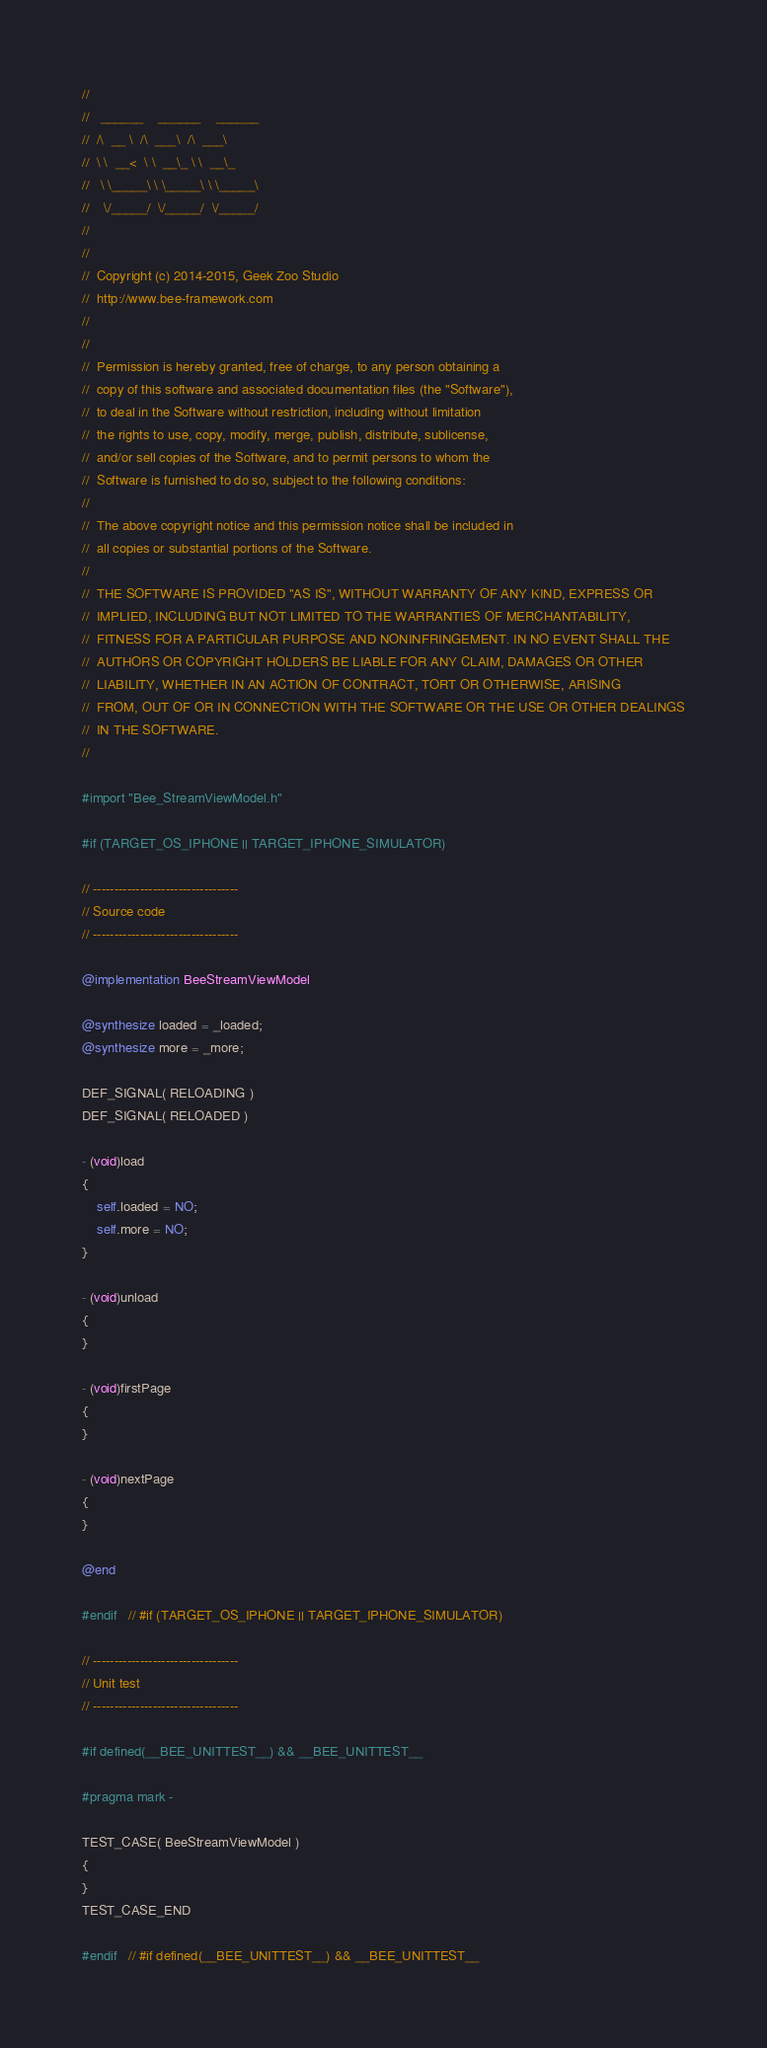<code> <loc_0><loc_0><loc_500><loc_500><_ObjectiveC_>//
//	 ______    ______    ______
//	/\  __ \  /\  ___\  /\  ___\
//	\ \  __<  \ \  __\_ \ \  __\_
//	 \ \_____\ \ \_____\ \ \_____\
//	  \/_____/  \/_____/  \/_____/
//
//
//	Copyright (c) 2014-2015, Geek Zoo Studio
//	http://www.bee-framework.com
//
//
//	Permission is hereby granted, free of charge, to any person obtaining a
//	copy of this software and associated documentation files (the "Software"),
//	to deal in the Software without restriction, including without limitation
//	the rights to use, copy, modify, merge, publish, distribute, sublicense,
//	and/or sell copies of the Software, and to permit persons to whom the
//	Software is furnished to do so, subject to the following conditions:
//
//	The above copyright notice and this permission notice shall be included in
//	all copies or substantial portions of the Software.
//
//	THE SOFTWARE IS PROVIDED "AS IS", WITHOUT WARRANTY OF ANY KIND, EXPRESS OR
//	IMPLIED, INCLUDING BUT NOT LIMITED TO THE WARRANTIES OF MERCHANTABILITY,
//	FITNESS FOR A PARTICULAR PURPOSE AND NONINFRINGEMENT. IN NO EVENT SHALL THE
//	AUTHORS OR COPYRIGHT HOLDERS BE LIABLE FOR ANY CLAIM, DAMAGES OR OTHER
//	LIABILITY, WHETHER IN AN ACTION OF CONTRACT, TORT OR OTHERWISE, ARISING
//	FROM, OUT OF OR IN CONNECTION WITH THE SOFTWARE OR THE USE OR OTHER DEALINGS
//	IN THE SOFTWARE.
//

#import "Bee_StreamViewModel.h"

#if (TARGET_OS_IPHONE || TARGET_IPHONE_SIMULATOR)

// ----------------------------------
// Source code
// ----------------------------------

@implementation BeeStreamViewModel

@synthesize loaded = _loaded;
@synthesize more = _more;

DEF_SIGNAL( RELOADING )
DEF_SIGNAL( RELOADED )

- (void)load
{
	self.loaded = NO;
	self.more = NO;
}

- (void)unload
{
}

- (void)firstPage
{
}

- (void)nextPage
{
}

@end

#endif	// #if (TARGET_OS_IPHONE || TARGET_IPHONE_SIMULATOR)

// ----------------------------------
// Unit test
// ----------------------------------

#if defined(__BEE_UNITTEST__) && __BEE_UNITTEST__

#pragma mark -

TEST_CASE( BeeStreamViewModel )
{
}
TEST_CASE_END

#endif	// #if defined(__BEE_UNITTEST__) && __BEE_UNITTEST__
</code> 